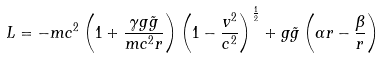Convert formula to latex. <formula><loc_0><loc_0><loc_500><loc_500>L = - m c ^ { 2 } \left ( 1 + \frac { \gamma g \tilde { g } } { m c ^ { 2 } r } \right ) \left ( 1 - \frac { v ^ { 2 } } { c ^ { 2 } } \right ) ^ { \frac { 1 } { 2 } } + g \tilde { g } \left ( \alpha r - \frac { \beta } { r } \right )</formula> 